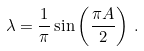<formula> <loc_0><loc_0><loc_500><loc_500>\lambda = \frac { 1 } { \pi } \sin \left ( \frac { \pi A } { 2 } \right ) \, .</formula> 